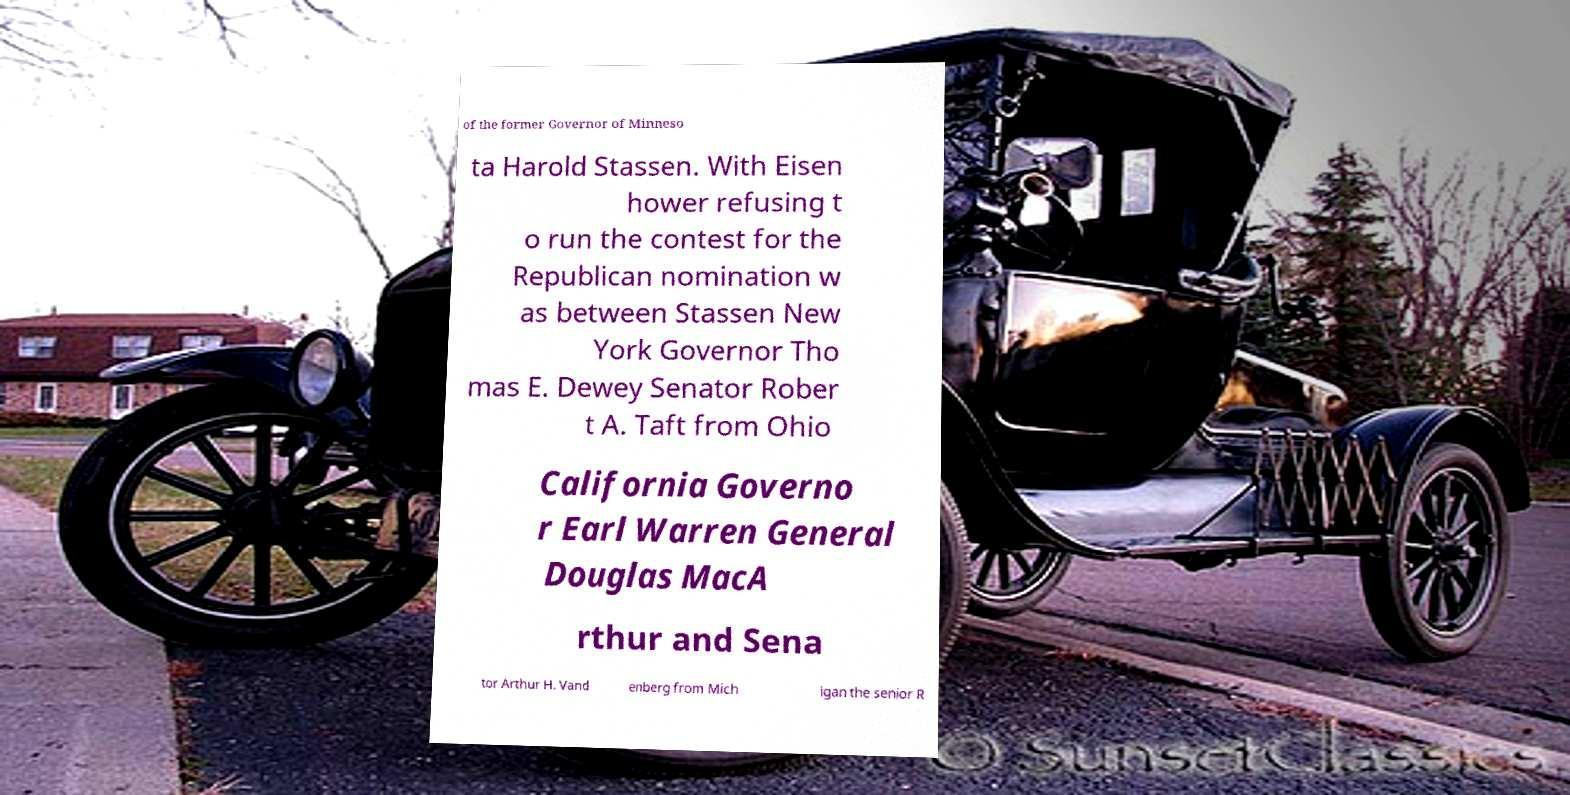Can you accurately transcribe the text from the provided image for me? of the former Governor of Minneso ta Harold Stassen. With Eisen hower refusing t o run the contest for the Republican nomination w as between Stassen New York Governor Tho mas E. Dewey Senator Rober t A. Taft from Ohio California Governo r Earl Warren General Douglas MacA rthur and Sena tor Arthur H. Vand enberg from Mich igan the senior R 